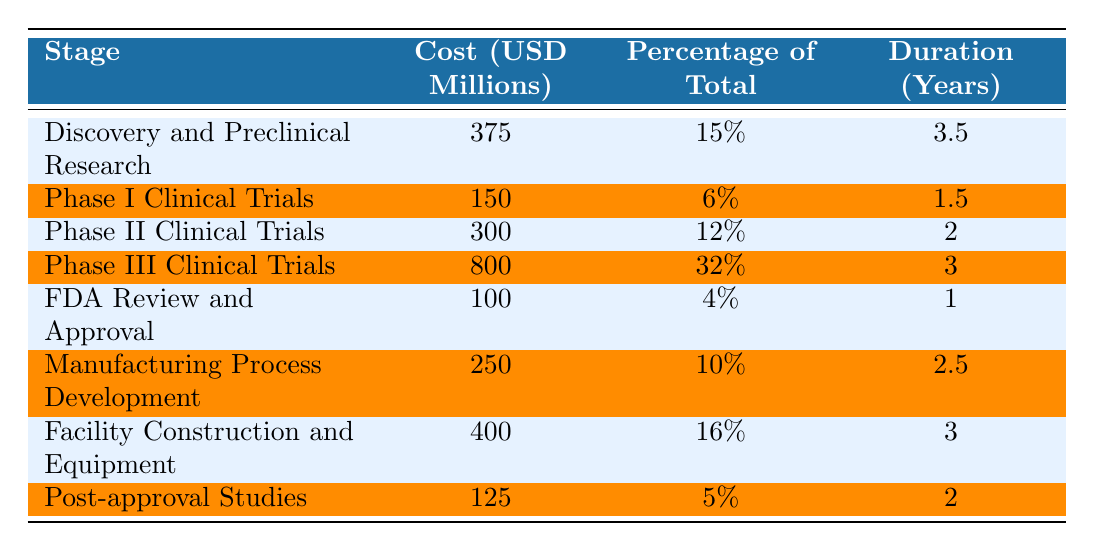What is the total cost of bringing a novel biologic drug to market? To find the total cost, sum the costs of all the stages listed in the table: 375 + 150 + 300 + 800 + 100 + 250 + 400 + 125 = 2500 million USD.
Answer: 2500 million USD Which stage has the highest cost? By examining the costs in the table, Phase III Clinical Trials has the highest cost at 800 million USD.
Answer: Phase III Clinical Trials What percentage of the total cost is allocated to the FDA Review and Approval stage? The table states that the FDA Review and Approval stage has a cost of 100 million USD, which is 4% of the total cost.
Answer: 4% How much more expensive is Phase III Clinical Trials compared to Phase I Clinical Trials? The cost of Phase III Clinical Trials is 800 million USD, while Phase I Clinical Trials costs 150 million USD. The difference is 800 - 150 = 650 million USD.
Answer: 650 million USD What is the average duration of all stages combined? Sum the durations: 3.5 + 1.5 + 2 + 3 + 1 + 2.5 + 3 + 2 = 18.5 years. There are 8 stages, so the average duration is 18.5 / 8 = 2.3125 years.
Answer: 2.31 years Does the Manufacturing Process Development stage cost more than the total cost of Phase I and Phase II Clinical Trials combined? The Manufacturing Process Development costs 250 million USD. The sum of Phase I (150 million) and Phase II (300 million) is 150 + 300 = 450 million USD. Since 250 million is less than 450 million, the statement is false.
Answer: No Which three stages together comprise 50% or more of the total cost? Adding the costs of the three highest stages: Phase III (800 million), Facility Construction (400 million), and Discovery (375 million): 800 + 400 + 375 = 1575 million USD, which is 63% of the total cost (2500 million).
Answer: Phase III, Facility Construction, Discovery What is the total percentage of costs associated with the Phase II and Post-approval Studies? Phase II has 12% and Post-approval Studies has 5%. Adding these together: 12 + 5 = 17%.
Answer: 17% Which stage takes the longest duration? The longest duration is in the Discovery and Preclinical Research stage, which takes 3.5 years.
Answer: Discovery and Preclinical Research How does the cost of Post-approval Studies compare with Facility Construction and Equipment? Post-approval Studies costs 125 million USD, while Facility Construction costs 400 million USD. Therefore, 125 million is less than 400 million.
Answer: Less expensive 